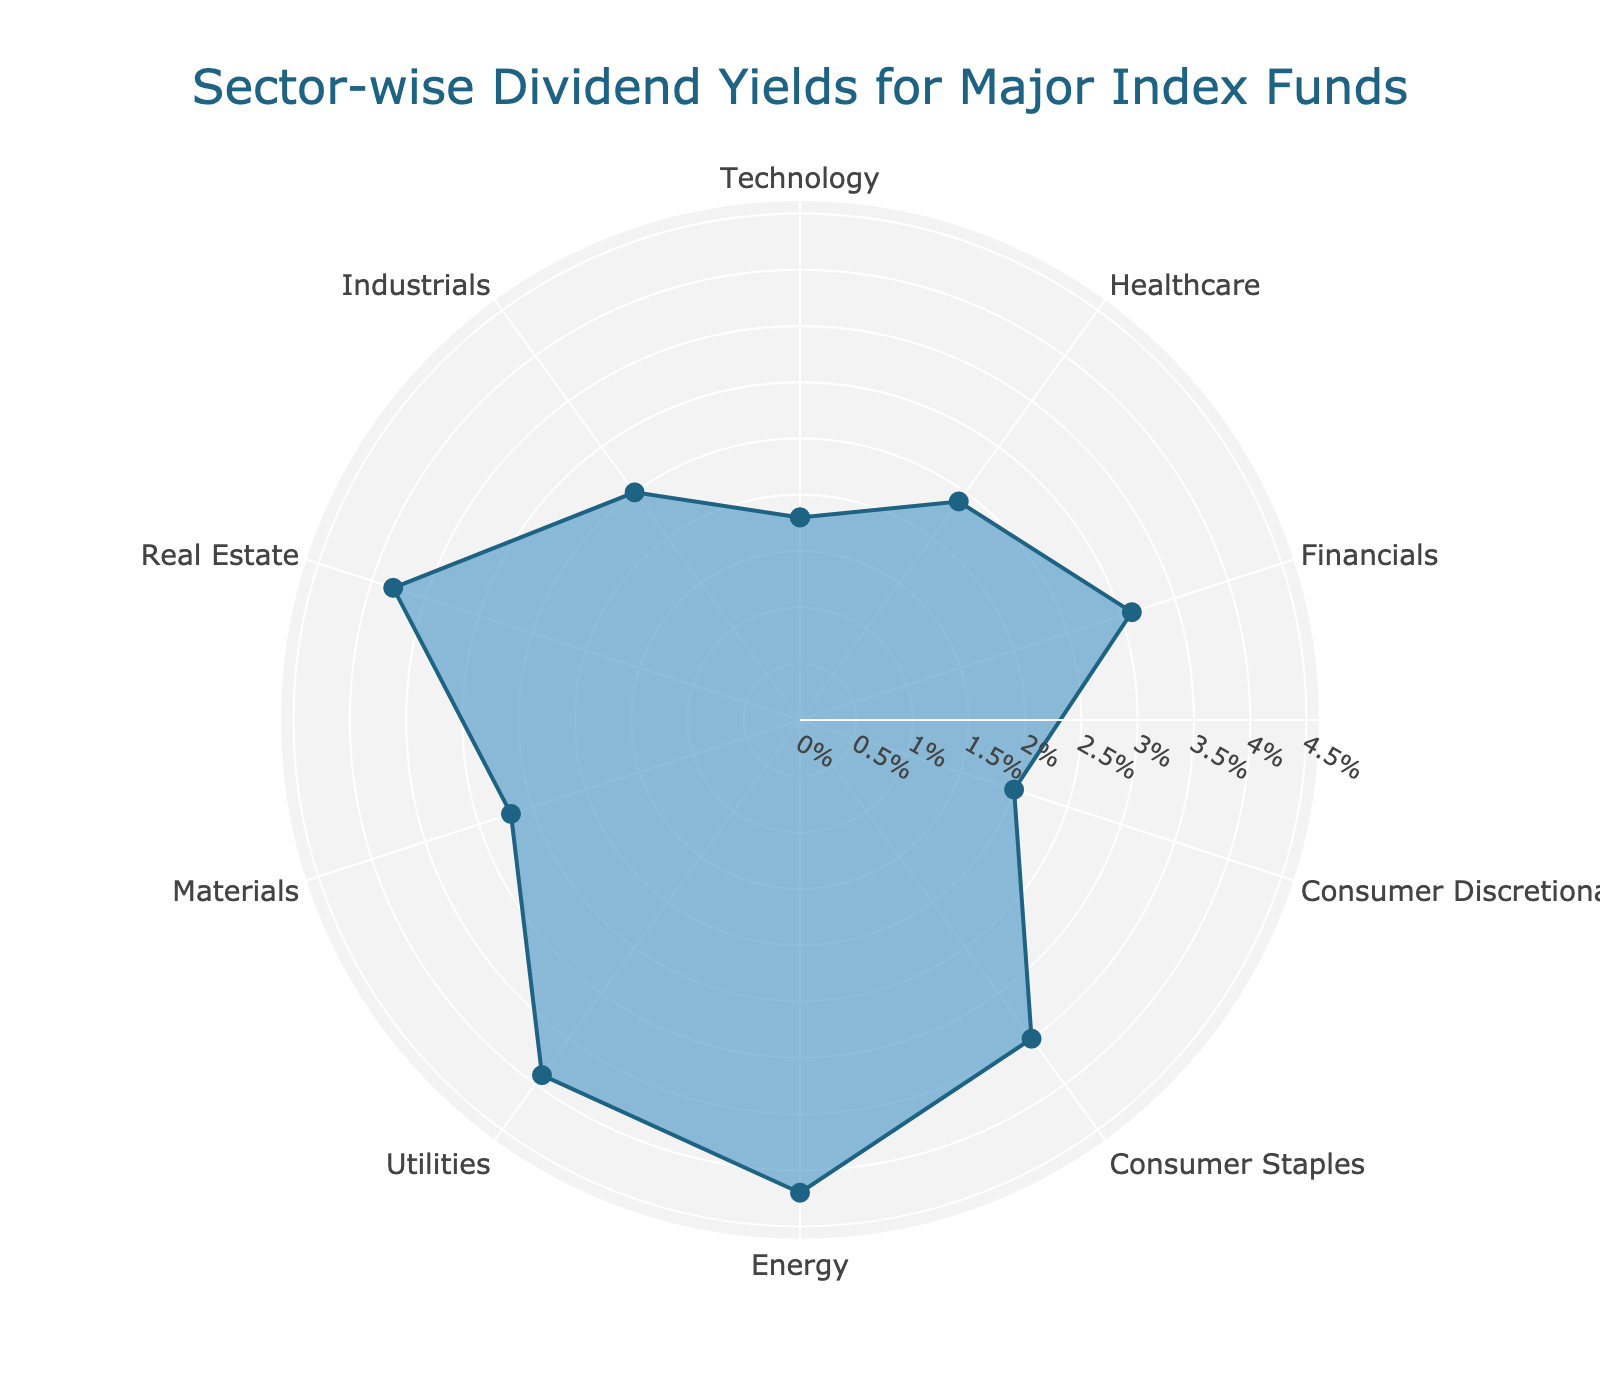What's the title of the figure? The title of the figure is prominently displayed at the top center of the chart.
Answer: Sector-wise Dividend Yields for Major Index Funds How many sectors are represented in the figure? By counting the distinct sector labels in the figure, we can determine the number of represented sectors.
Answer: 10 Which sector has the highest dividend yield? The sector with the highest point on the radial axis represents the highest dividend yield.
Answer: Energy What is the dividend yield for the Healthcare sector? Locate the "Healthcare" label on the chart and note the corresponding dividend yield value on the radial axis.
Answer: 2.4% Which sectors have higher yields than Consumer Staples? Compare the dividend yields of other sectors to the dividend yield of Consumer Staples.
Answer: Energy, Utilities, Real Estate What's the difference in dividend yield between Technology and Financials? The dividend yield of Financials (3.1%) minus the dividend yield of Technology (1.8%) gives us the difference.
Answer: 1.3% What is the average dividend yield of the sectors Consumer Discretionary, Real Estate, and Industrials? Adding their yields: (2.0% + 3.8% + 2.5%) = 8.3%, then divide by 3 to get the average.
Answer: 2.77% Which sectors have a dividend yield of at least 3%? Identify and list the sectors with yields 3% or higher from the chart.
Answer: Financials, Consumer Staples, Energy, Utilities, Real Estate What is the total dividend yield if you sum up Healthcare and Utilities? Adding the dividend yields of Healthcare (2.4%) and Utilities (3.9%).
Answer: 6.3% Is the dividend yield of Materials greater than that of Consumer Discretionary? Compare the dividend yield values of Materials and Consumer Discretionary directly from the radial axis markers.
Answer: Yes 